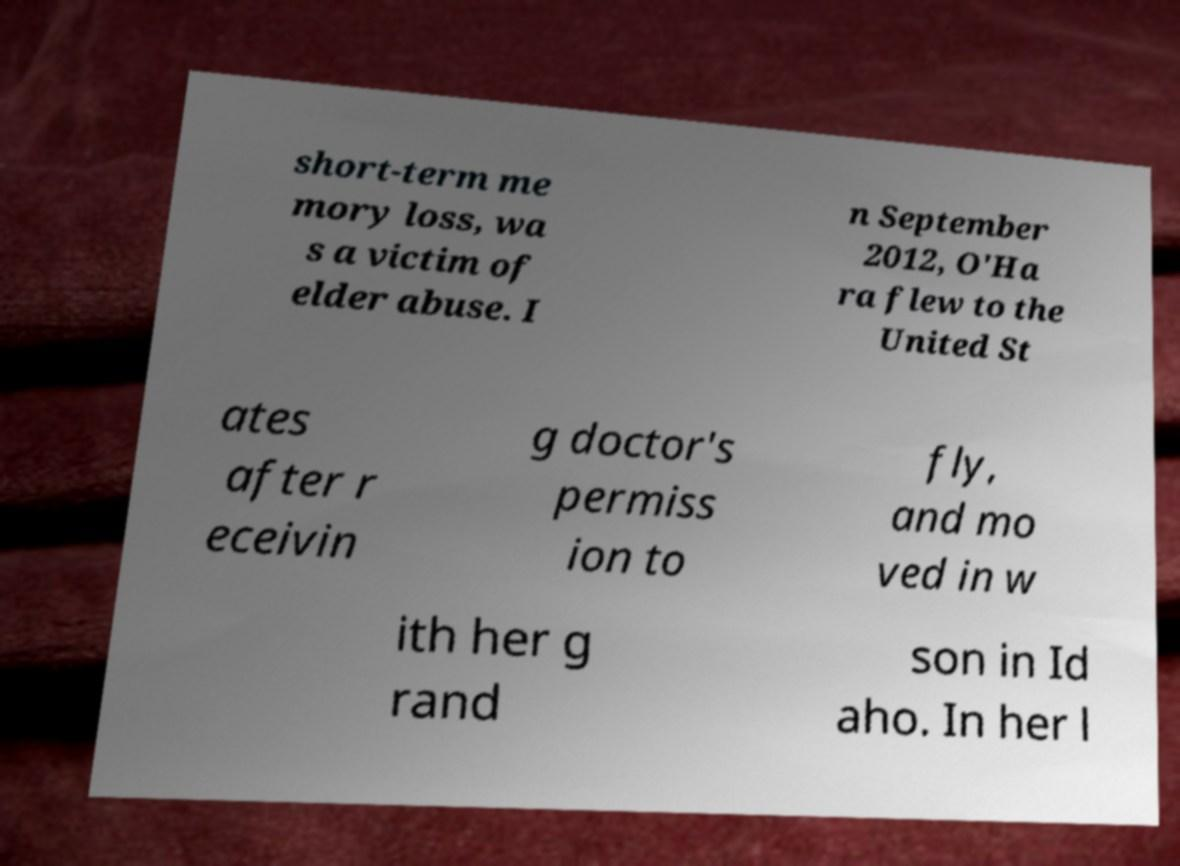Can you read and provide the text displayed in the image?This photo seems to have some interesting text. Can you extract and type it out for me? short-term me mory loss, wa s a victim of elder abuse. I n September 2012, O'Ha ra flew to the United St ates after r eceivin g doctor's permiss ion to fly, and mo ved in w ith her g rand son in Id aho. In her l 